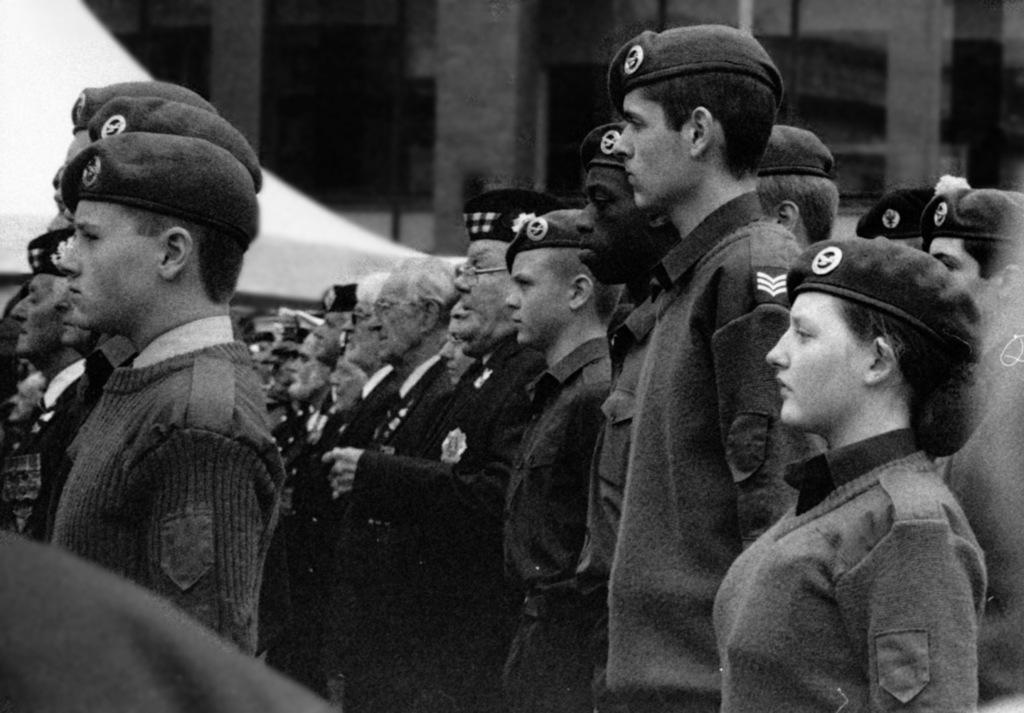What is the color scheme of the image? The image is black and white. Who can be seen in the image? There are boys, men, and old people in the image. How are they positioned in the image? They are standing in a line. What are they wearing in the image? They are wearing scout uniforms. What type of light can be seen in the image? There is no light source visible in the image, as it is black and white. What kind of rail is present in the image? There is no rail present in the image; it features a line of people wearing scout uniforms. 